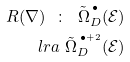<formula> <loc_0><loc_0><loc_500><loc_500>R ( \nabla ) \ \colon \ \tilde { \Omega } _ { D } ^ { \, ^ { \bullet } } ( { \mathcal { E } } ) \\ l r a \ \tilde { \Omega } _ { D } ^ { \, ^ { \bullet + 2 } } ( { \mathcal { E } } )</formula> 